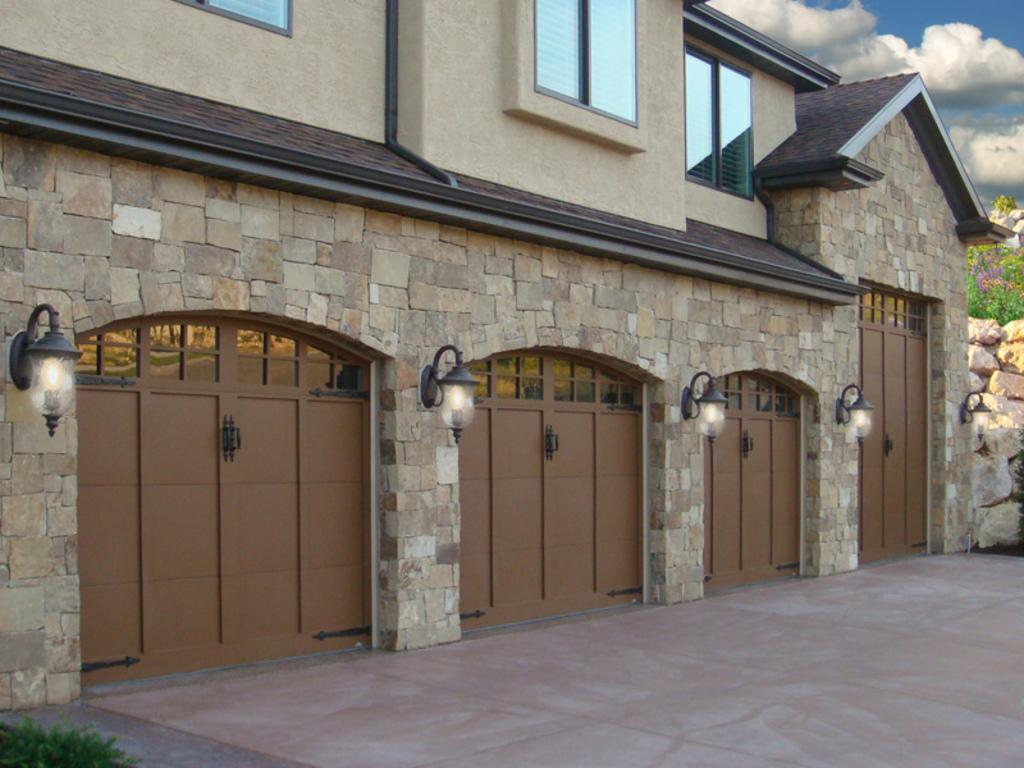What is the main structure in the image? There is a building in the image. What feature of the building is mentioned in the facts? The building has lights. What part of the natural environment is visible in the image? The sky is visible in the top right of the image. Where is the girl standing in the image? There is no girl present in the image. What is the ant doing in the image? There is no ant present in the image. 